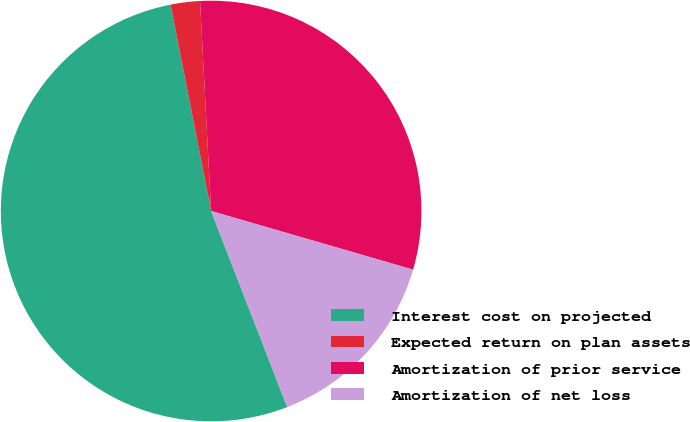<chart> <loc_0><loc_0><loc_500><loc_500><pie_chart><fcel>Interest cost on projected<fcel>Expected return on plan assets<fcel>Amortization of prior service<fcel>Amortization of net loss<nl><fcel>52.81%<fcel>2.25%<fcel>30.34%<fcel>14.61%<nl></chart> 